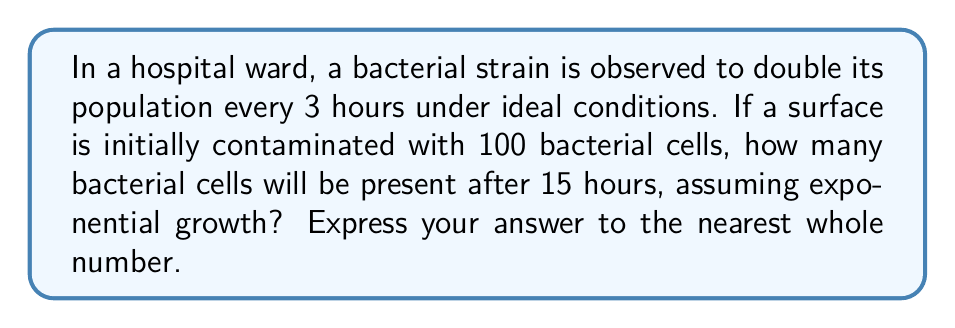What is the answer to this math problem? To solve this problem, we'll use the exponential growth model and follow these steps:

1) The exponential growth formula is:

   $$N(t) = N_0 \cdot 2^{\frac{t}{d}}$$

   Where:
   $N(t)$ is the number of bacteria at time $t$
   $N_0$ is the initial number of bacteria
   $t$ is the time elapsed
   $d$ is the doubling time

2) We're given:
   $N_0 = 100$ (initial bacterial count)
   $d = 3$ hours (doubling time)
   $t = 15$ hours (elapsed time)

3) Substituting these values into the formula:

   $$N(15) = 100 \cdot 2^{\frac{15}{3}}$$

4) Simplify the exponent:

   $$N(15) = 100 \cdot 2^5$$

5) Calculate $2^5$:

   $$N(15) = 100 \cdot 32$$

6) Multiply:

   $$N(15) = 3200$$

Therefore, after 15 hours, there will be 3200 bacterial cells.
Answer: 3200 bacterial cells 